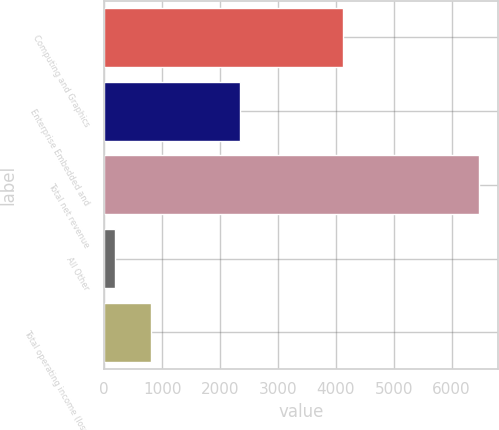Convert chart. <chart><loc_0><loc_0><loc_500><loc_500><bar_chart><fcel>Computing and Graphics<fcel>Enterprise Embedded and<fcel>Total net revenue<fcel>All Other<fcel>Total operating income (loss)<nl><fcel>4125<fcel>2350<fcel>6475<fcel>182<fcel>811.3<nl></chart> 